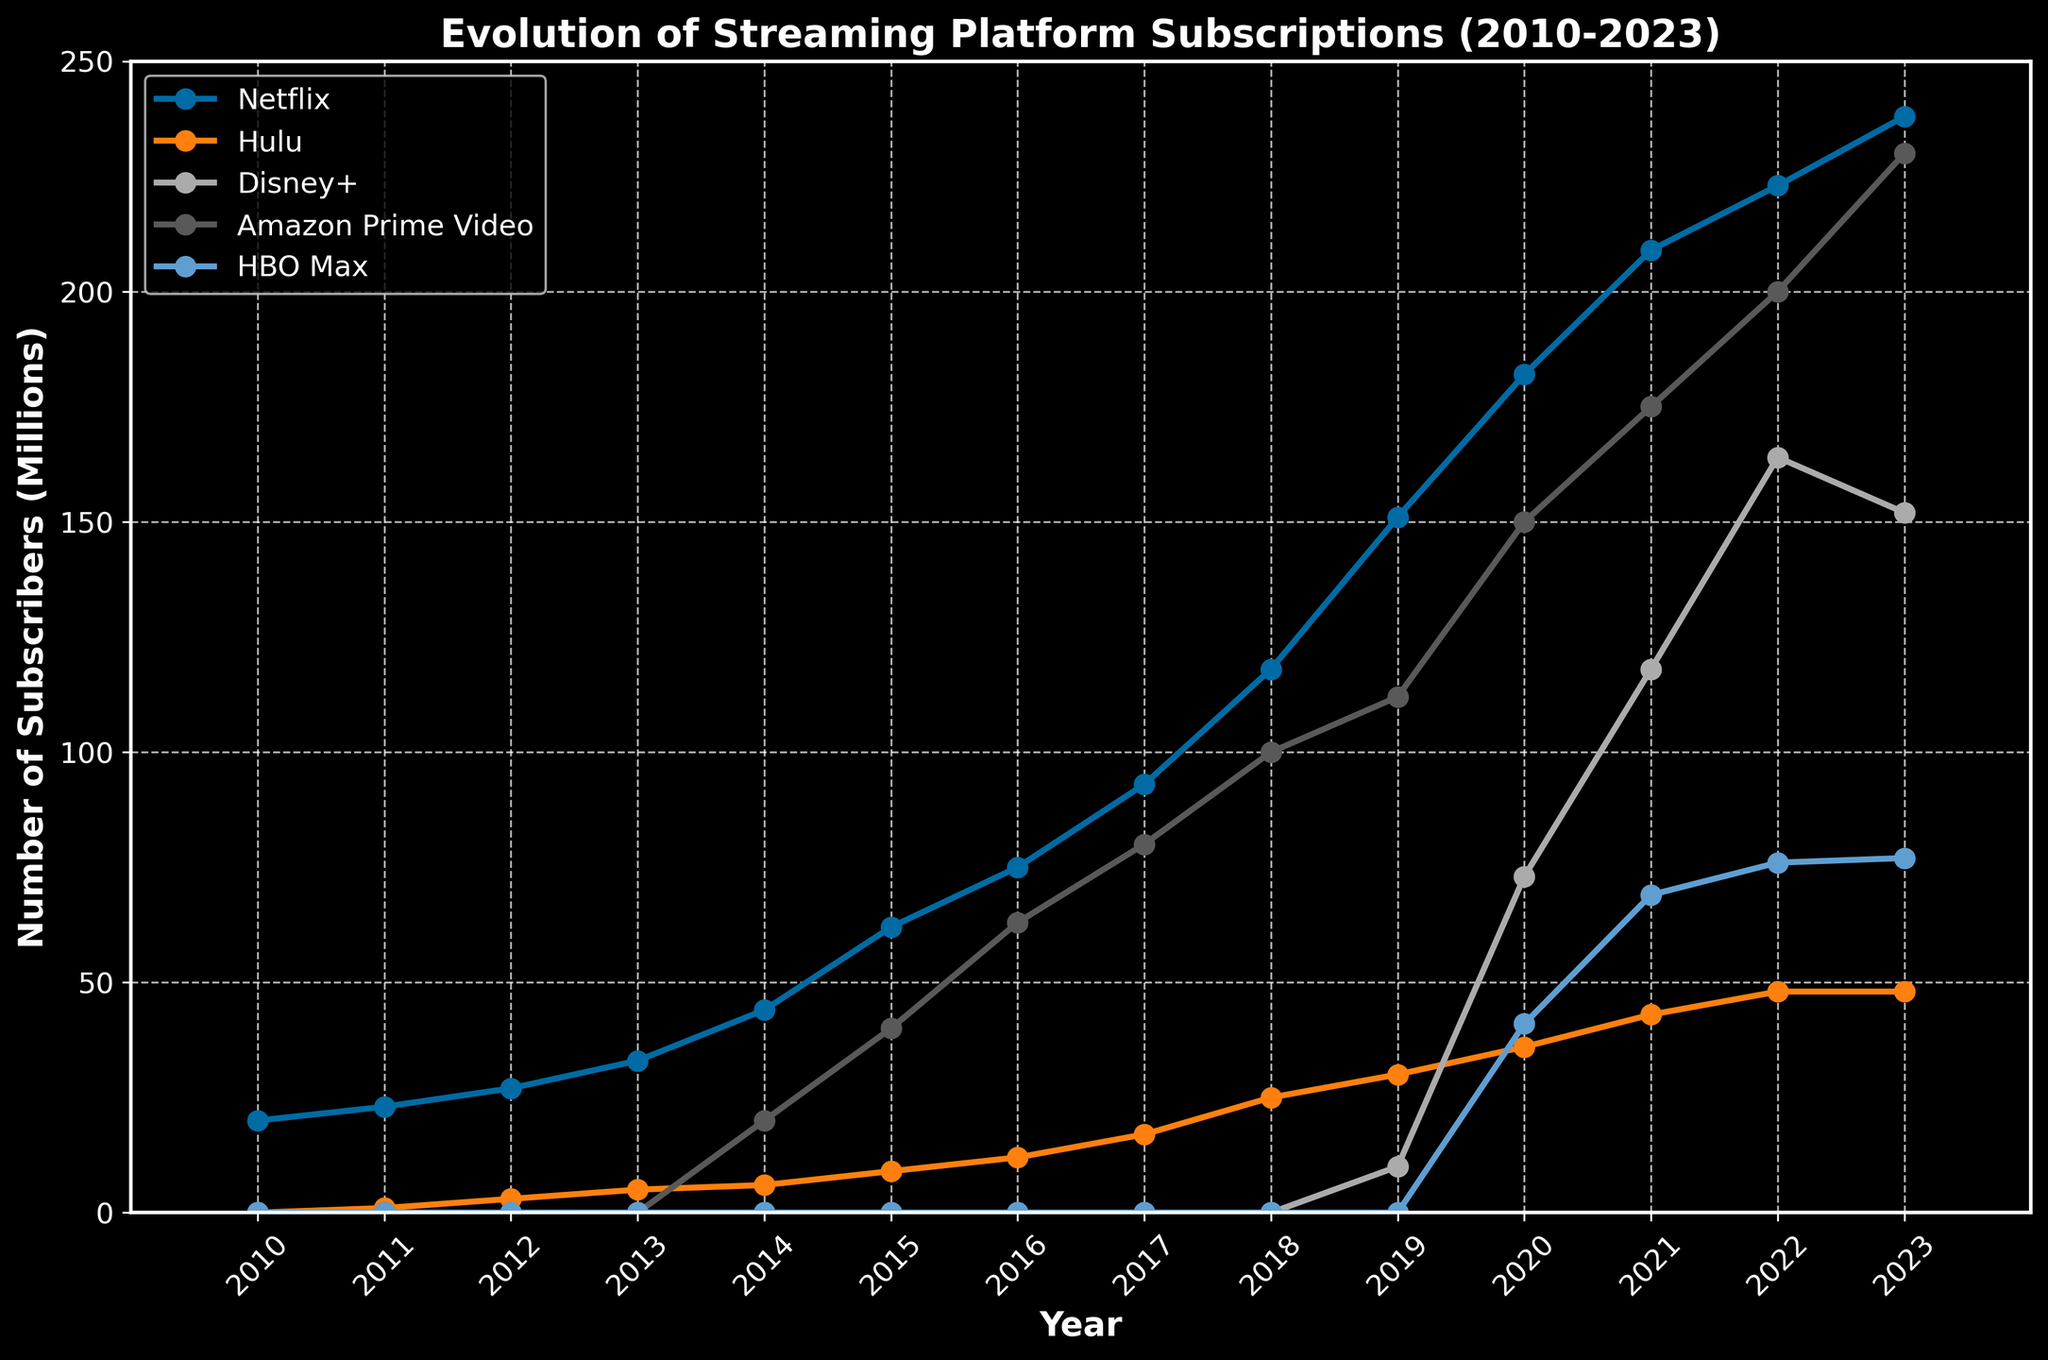What's the trend for Netflix's subscriber growth between 2010 and 2023? Identify the points for Netflix each year and observe the general direction they form; Netflix's subscribers increase steadily from 20 million in 2010 to 238 million in 2023
Answer: Steadily increasing How does Disney+'s subscriber growth between 2019 and 2023 compare to Hulu's growth over the same period? Identify the subscriber numbers for Disney+ (10 to 152 million) and Hulu (30 to 48 million) from 2019 to 2023, then compare the differences; Disney+'s growth (142 million) is much higher than Hulu's (18 million)
Answer: Disney+ grew more What year did Amazon Prime Video surpass 100 million subscribers? Locate the trend line for Amazon Prime Video and find when it crosses the 100-million mark, which happens in 2018
Answer: 2018 Between 2020 and 2023, which streaming service showed the least amount of subscriber growth, and by what amount? Calculate the difference between 2020 and 2023 for each service: Netflix (238-182=56), Hulu (48-36=12), Disney+ (152-73=79), Amazon Prime Video (230-150=80), and HBO Max (77-41=36); Hulu has the least growth
Answer: Hulu, 12 million Which streaming service had the most subscribers in 2016? Compare the subscriber numbers for all services in 2016: Netflix (75 million), Hulu (12 million), Amazon Prime Video (63 million); Netflix has the most
Answer: Netflix Did HBO Max ever have more subscribers than Hulu from 2010 to 2023? Compare the subscribers for HBO Max and Hulu each year; HBO Max's peak (77 million in 2023) never surpasses Hulu's peak (48 million in 2023)
Answer: No What’s the average subscriber count for Amazon Prime Video between 2014 and 2023? Calculate the average by summing the subscribers from 2014-2023 (20+40+63+80+100+112+150+175+200+230) = 1170, then divide by the number of years (10); the average is 117
Answer: 117 million Which streaming platform showed the highest percentage growth from 2020 to 2021? Calculate the percentage growth for 2020-2021 for each platform: 
Netflix: [(209-182)/182]*100 = 14.8%
Hulu: [(43-36)/36]*100 = 19.4%
Disney+: [(118-73)/73]*100 = 61.6%
Amazon Prime Video: [(175-150)/150]*100 = 16.7%
HBO Max: [(69-41)/41]*100 = 68.3%;
Disney+ has the highest percentage growth
Answer: Disney+ In what year did Disney+ first appear on the chart, and how many subscribers did it have that year? Identify the first year Disney+ appears on the chart and read the subscriber count for that year; Disney+ first appears in 2019 with 10 million subscribers
Answer: 2019, 10 million By how much did Netflix's subscribers increase from 2014 to 2015 compared to Hulu's growth in the same period? Calculate the increase for Netflix (62-44=18 million) and for Hulu (9-6=3 million); the difference is 18 - 3 = 15 million more subscribers for Netflix
Answer: 15 million more for Netflix 